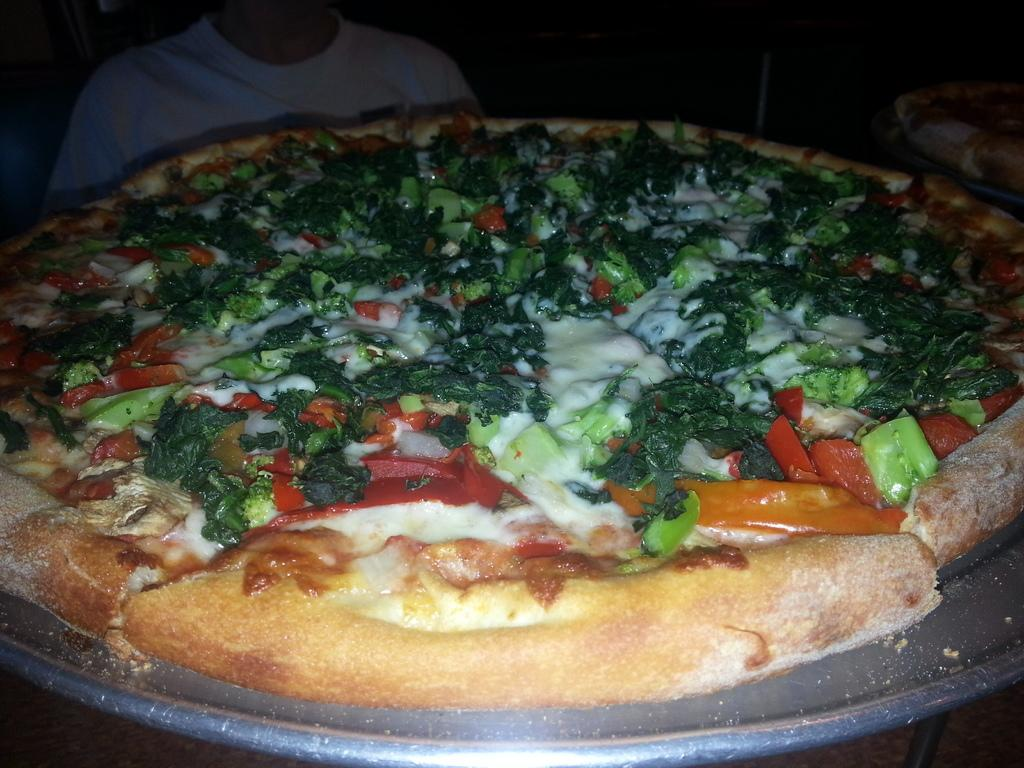What type of establishment is shown in the image? There is a pizza place in the image. How is the pizza presented in the image? The pizza is on a plate. Who is present in the image? There is a boy in the image. What is the boy doing in the image? The boy is sitting on a chair. What time is the boy expected to be released from jail in the image? There is no mention of a jail or any legal situation in the image; the boy is simply sitting on a chair in a pizza place. 